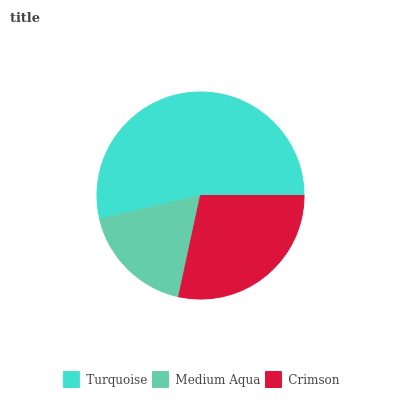Is Medium Aqua the minimum?
Answer yes or no. Yes. Is Turquoise the maximum?
Answer yes or no. Yes. Is Crimson the minimum?
Answer yes or no. No. Is Crimson the maximum?
Answer yes or no. No. Is Crimson greater than Medium Aqua?
Answer yes or no. Yes. Is Medium Aqua less than Crimson?
Answer yes or no. Yes. Is Medium Aqua greater than Crimson?
Answer yes or no. No. Is Crimson less than Medium Aqua?
Answer yes or no. No. Is Crimson the high median?
Answer yes or no. Yes. Is Crimson the low median?
Answer yes or no. Yes. Is Medium Aqua the high median?
Answer yes or no. No. Is Medium Aqua the low median?
Answer yes or no. No. 